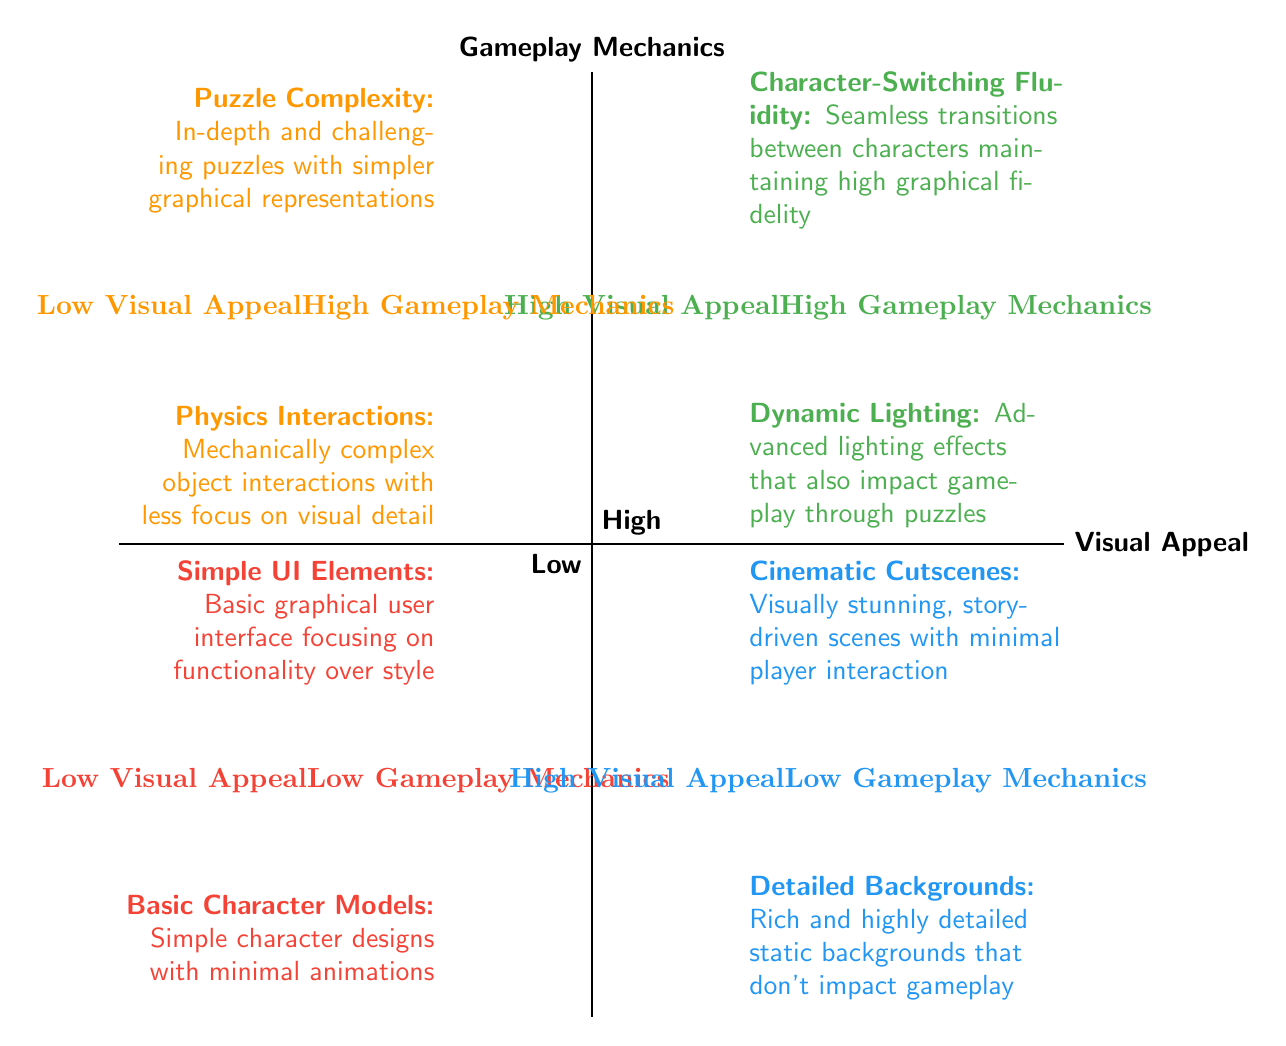What features are classified under High Visual Appeal - High Gameplay Mechanics? The diagram indicates that the features "Character-Switching Fluidity" and "Dynamic Lighting" are located in the quadrant for High Visual Appeal and High Gameplay Mechanics.
Answer: Character-Switching Fluidity, Dynamic Lighting How many features are categorized as Low Visual Appeal - Low Gameplay Mechanics? The diagram shows two features listed in the Low Visual Appeal - Low Gameplay Mechanics quadrant: "Simple UI Elements" and "Basic Character Models", making a total of two features.
Answer: 2 Which feature has High Visual Appeal but Low Gameplay Mechanics? The quadrant for High Visual Appeal and Low Gameplay Mechanics displays "Cinematic Cutscenes" and "Detailed Backgrounds". Both are under this classification.
Answer: Cinematic Cutscenes, Detailed Backgrounds What is the common characteristic of features in the Low Visual Appeal - High Gameplay Mechanics quadrant? Features in this quadrant, such as "Puzzle Complexity" and "Physics Interactions", are characterized by in-depth gameplay mechanics with simpler visual designs focused on functionality rather than aesthetics.
Answer: Simpler visual designs Which two quadrants contain features that impact gameplay mechanics? The quadrants that contain features impacting gameplay mechanics are "High Visual Appeal - High Gameplay Mechanics" and "Low Visual Appeal - High Gameplay Mechanics". Both quadrants include features that enhance gameplay.
Answer: High Visual Appeal - High Gameplay Mechanics, Low Visual Appeal - High Gameplay Mechanics What can be inferred about the relationship between visual appeal and gameplay mechanics from the diagram? The diagram suggests that as visual appeal increases, gameplay mechanics can also be high, illustrating that high-quality visuals can coincide with engaging gameplay. Conversely, low visual appeal may still include complex mechanics.
Answer: High-quality visuals can coincide with engaging gameplay 